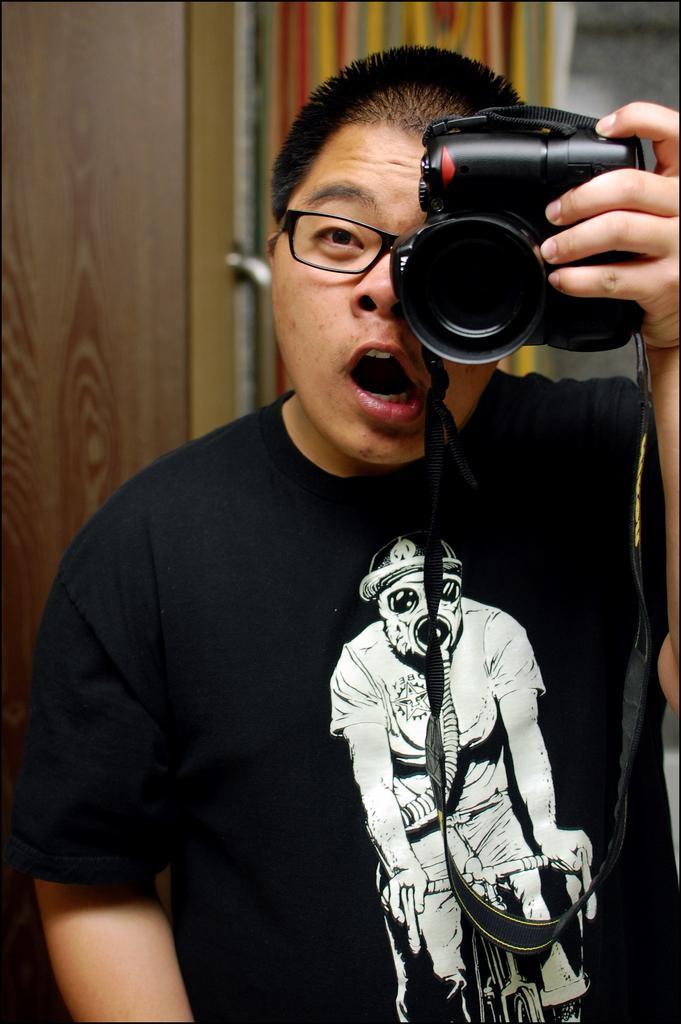Describe this image in one or two sentences. Here is the man wearing black T-shirt and holding camera in his hand. At background this looks like a door with a door handle. 